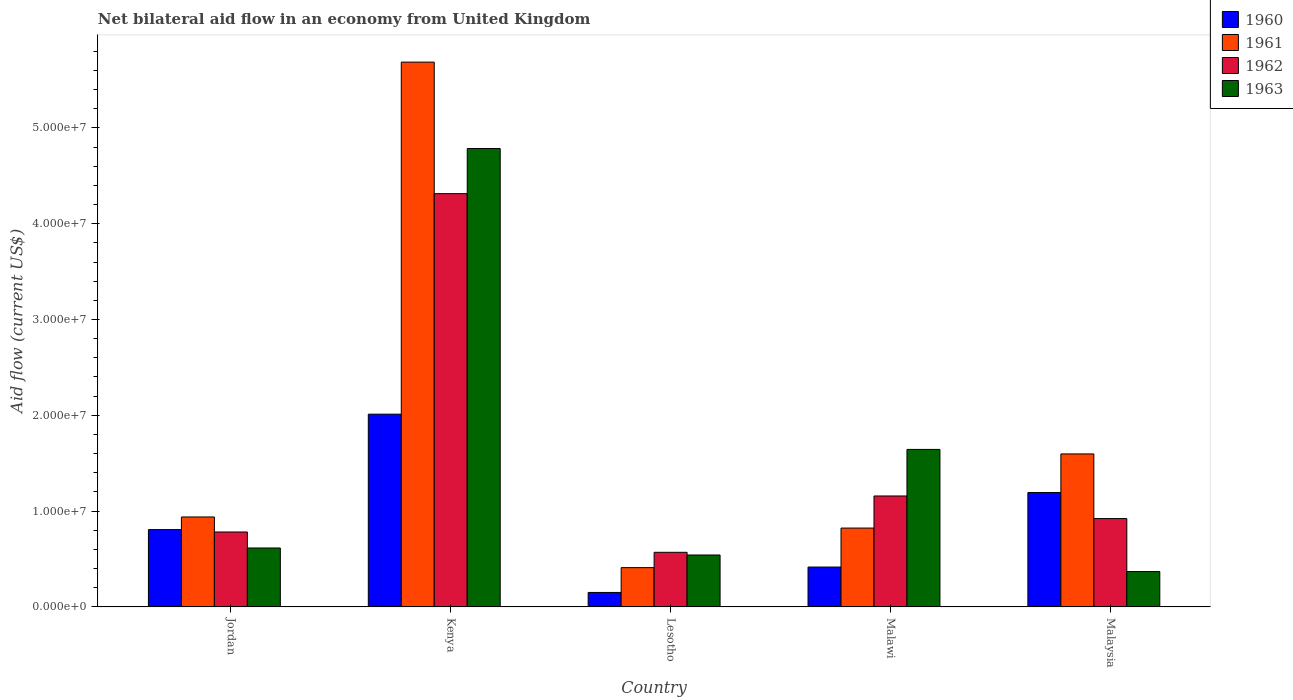How many groups of bars are there?
Your answer should be very brief. 5. Are the number of bars per tick equal to the number of legend labels?
Make the answer very short. Yes. Are the number of bars on each tick of the X-axis equal?
Provide a short and direct response. Yes. What is the label of the 2nd group of bars from the left?
Give a very brief answer. Kenya. In how many cases, is the number of bars for a given country not equal to the number of legend labels?
Your answer should be very brief. 0. What is the net bilateral aid flow in 1962 in Lesotho?
Offer a terse response. 5.70e+06. Across all countries, what is the maximum net bilateral aid flow in 1960?
Your answer should be compact. 2.01e+07. Across all countries, what is the minimum net bilateral aid flow in 1961?
Ensure brevity in your answer.  4.10e+06. In which country was the net bilateral aid flow in 1963 maximum?
Your answer should be very brief. Kenya. In which country was the net bilateral aid flow in 1963 minimum?
Your answer should be very brief. Malaysia. What is the total net bilateral aid flow in 1960 in the graph?
Your answer should be compact. 4.58e+07. What is the difference between the net bilateral aid flow in 1962 in Lesotho and that in Malaysia?
Provide a succinct answer. -3.52e+06. What is the difference between the net bilateral aid flow in 1960 in Malaysia and the net bilateral aid flow in 1962 in Lesotho?
Make the answer very short. 6.24e+06. What is the average net bilateral aid flow in 1960 per country?
Ensure brevity in your answer.  9.16e+06. What is the difference between the net bilateral aid flow of/in 1960 and net bilateral aid flow of/in 1961 in Jordan?
Ensure brevity in your answer.  -1.32e+06. In how many countries, is the net bilateral aid flow in 1962 greater than 28000000 US$?
Offer a terse response. 1. What is the ratio of the net bilateral aid flow in 1961 in Kenya to that in Malaysia?
Your answer should be compact. 3.56. What is the difference between the highest and the second highest net bilateral aid flow in 1963?
Your response must be concise. 4.17e+07. What is the difference between the highest and the lowest net bilateral aid flow in 1960?
Ensure brevity in your answer.  1.86e+07. In how many countries, is the net bilateral aid flow in 1960 greater than the average net bilateral aid flow in 1960 taken over all countries?
Ensure brevity in your answer.  2. What does the 4th bar from the left in Malawi represents?
Make the answer very short. 1963. Is it the case that in every country, the sum of the net bilateral aid flow in 1963 and net bilateral aid flow in 1962 is greater than the net bilateral aid flow in 1961?
Provide a succinct answer. No. Are all the bars in the graph horizontal?
Offer a very short reply. No. What is the difference between two consecutive major ticks on the Y-axis?
Give a very brief answer. 1.00e+07. Does the graph contain any zero values?
Offer a very short reply. No. Does the graph contain grids?
Provide a succinct answer. No. Where does the legend appear in the graph?
Keep it short and to the point. Top right. How are the legend labels stacked?
Provide a succinct answer. Vertical. What is the title of the graph?
Your answer should be compact. Net bilateral aid flow in an economy from United Kingdom. Does "1968" appear as one of the legend labels in the graph?
Provide a short and direct response. No. What is the Aid flow (current US$) in 1960 in Jordan?
Your answer should be compact. 8.07e+06. What is the Aid flow (current US$) of 1961 in Jordan?
Keep it short and to the point. 9.39e+06. What is the Aid flow (current US$) in 1962 in Jordan?
Provide a succinct answer. 7.82e+06. What is the Aid flow (current US$) of 1963 in Jordan?
Offer a terse response. 6.15e+06. What is the Aid flow (current US$) in 1960 in Kenya?
Your answer should be compact. 2.01e+07. What is the Aid flow (current US$) in 1961 in Kenya?
Provide a short and direct response. 5.69e+07. What is the Aid flow (current US$) of 1962 in Kenya?
Make the answer very short. 4.31e+07. What is the Aid flow (current US$) in 1963 in Kenya?
Ensure brevity in your answer.  4.78e+07. What is the Aid flow (current US$) of 1960 in Lesotho?
Provide a succinct answer. 1.51e+06. What is the Aid flow (current US$) in 1961 in Lesotho?
Keep it short and to the point. 4.10e+06. What is the Aid flow (current US$) of 1962 in Lesotho?
Offer a very short reply. 5.70e+06. What is the Aid flow (current US$) of 1963 in Lesotho?
Provide a short and direct response. 5.42e+06. What is the Aid flow (current US$) in 1960 in Malawi?
Offer a very short reply. 4.16e+06. What is the Aid flow (current US$) of 1961 in Malawi?
Provide a short and direct response. 8.23e+06. What is the Aid flow (current US$) of 1962 in Malawi?
Your answer should be very brief. 1.16e+07. What is the Aid flow (current US$) of 1963 in Malawi?
Give a very brief answer. 1.64e+07. What is the Aid flow (current US$) in 1960 in Malaysia?
Provide a succinct answer. 1.19e+07. What is the Aid flow (current US$) in 1961 in Malaysia?
Provide a succinct answer. 1.60e+07. What is the Aid flow (current US$) in 1962 in Malaysia?
Offer a very short reply. 9.22e+06. What is the Aid flow (current US$) of 1963 in Malaysia?
Keep it short and to the point. 3.69e+06. Across all countries, what is the maximum Aid flow (current US$) of 1960?
Offer a terse response. 2.01e+07. Across all countries, what is the maximum Aid flow (current US$) of 1961?
Offer a terse response. 5.69e+07. Across all countries, what is the maximum Aid flow (current US$) in 1962?
Offer a terse response. 4.31e+07. Across all countries, what is the maximum Aid flow (current US$) in 1963?
Your answer should be very brief. 4.78e+07. Across all countries, what is the minimum Aid flow (current US$) in 1960?
Your answer should be very brief. 1.51e+06. Across all countries, what is the minimum Aid flow (current US$) in 1961?
Offer a terse response. 4.10e+06. Across all countries, what is the minimum Aid flow (current US$) in 1962?
Provide a short and direct response. 5.70e+06. Across all countries, what is the minimum Aid flow (current US$) in 1963?
Your response must be concise. 3.69e+06. What is the total Aid flow (current US$) of 1960 in the graph?
Offer a terse response. 4.58e+07. What is the total Aid flow (current US$) of 1961 in the graph?
Ensure brevity in your answer.  9.46e+07. What is the total Aid flow (current US$) of 1962 in the graph?
Offer a terse response. 7.75e+07. What is the total Aid flow (current US$) in 1963 in the graph?
Keep it short and to the point. 7.96e+07. What is the difference between the Aid flow (current US$) in 1960 in Jordan and that in Kenya?
Make the answer very short. -1.20e+07. What is the difference between the Aid flow (current US$) of 1961 in Jordan and that in Kenya?
Ensure brevity in your answer.  -4.75e+07. What is the difference between the Aid flow (current US$) of 1962 in Jordan and that in Kenya?
Ensure brevity in your answer.  -3.53e+07. What is the difference between the Aid flow (current US$) of 1963 in Jordan and that in Kenya?
Offer a very short reply. -4.17e+07. What is the difference between the Aid flow (current US$) of 1960 in Jordan and that in Lesotho?
Offer a terse response. 6.56e+06. What is the difference between the Aid flow (current US$) in 1961 in Jordan and that in Lesotho?
Your answer should be very brief. 5.29e+06. What is the difference between the Aid flow (current US$) of 1962 in Jordan and that in Lesotho?
Provide a short and direct response. 2.12e+06. What is the difference between the Aid flow (current US$) in 1963 in Jordan and that in Lesotho?
Provide a short and direct response. 7.30e+05. What is the difference between the Aid flow (current US$) of 1960 in Jordan and that in Malawi?
Keep it short and to the point. 3.91e+06. What is the difference between the Aid flow (current US$) in 1961 in Jordan and that in Malawi?
Provide a short and direct response. 1.16e+06. What is the difference between the Aid flow (current US$) in 1962 in Jordan and that in Malawi?
Your answer should be compact. -3.76e+06. What is the difference between the Aid flow (current US$) in 1963 in Jordan and that in Malawi?
Your answer should be compact. -1.03e+07. What is the difference between the Aid flow (current US$) of 1960 in Jordan and that in Malaysia?
Make the answer very short. -3.87e+06. What is the difference between the Aid flow (current US$) of 1961 in Jordan and that in Malaysia?
Offer a terse response. -6.58e+06. What is the difference between the Aid flow (current US$) of 1962 in Jordan and that in Malaysia?
Make the answer very short. -1.40e+06. What is the difference between the Aid flow (current US$) in 1963 in Jordan and that in Malaysia?
Make the answer very short. 2.46e+06. What is the difference between the Aid flow (current US$) in 1960 in Kenya and that in Lesotho?
Your answer should be compact. 1.86e+07. What is the difference between the Aid flow (current US$) in 1961 in Kenya and that in Lesotho?
Make the answer very short. 5.28e+07. What is the difference between the Aid flow (current US$) of 1962 in Kenya and that in Lesotho?
Provide a short and direct response. 3.74e+07. What is the difference between the Aid flow (current US$) in 1963 in Kenya and that in Lesotho?
Offer a terse response. 4.24e+07. What is the difference between the Aid flow (current US$) in 1960 in Kenya and that in Malawi?
Ensure brevity in your answer.  1.60e+07. What is the difference between the Aid flow (current US$) in 1961 in Kenya and that in Malawi?
Provide a succinct answer. 4.86e+07. What is the difference between the Aid flow (current US$) of 1962 in Kenya and that in Malawi?
Give a very brief answer. 3.16e+07. What is the difference between the Aid flow (current US$) in 1963 in Kenya and that in Malawi?
Make the answer very short. 3.14e+07. What is the difference between the Aid flow (current US$) in 1960 in Kenya and that in Malaysia?
Provide a short and direct response. 8.18e+06. What is the difference between the Aid flow (current US$) in 1961 in Kenya and that in Malaysia?
Offer a very short reply. 4.09e+07. What is the difference between the Aid flow (current US$) in 1962 in Kenya and that in Malaysia?
Offer a very short reply. 3.39e+07. What is the difference between the Aid flow (current US$) in 1963 in Kenya and that in Malaysia?
Offer a very short reply. 4.42e+07. What is the difference between the Aid flow (current US$) in 1960 in Lesotho and that in Malawi?
Provide a succinct answer. -2.65e+06. What is the difference between the Aid flow (current US$) in 1961 in Lesotho and that in Malawi?
Give a very brief answer. -4.13e+06. What is the difference between the Aid flow (current US$) in 1962 in Lesotho and that in Malawi?
Provide a short and direct response. -5.88e+06. What is the difference between the Aid flow (current US$) of 1963 in Lesotho and that in Malawi?
Provide a succinct answer. -1.10e+07. What is the difference between the Aid flow (current US$) in 1960 in Lesotho and that in Malaysia?
Make the answer very short. -1.04e+07. What is the difference between the Aid flow (current US$) of 1961 in Lesotho and that in Malaysia?
Offer a very short reply. -1.19e+07. What is the difference between the Aid flow (current US$) in 1962 in Lesotho and that in Malaysia?
Offer a very short reply. -3.52e+06. What is the difference between the Aid flow (current US$) of 1963 in Lesotho and that in Malaysia?
Make the answer very short. 1.73e+06. What is the difference between the Aid flow (current US$) of 1960 in Malawi and that in Malaysia?
Offer a terse response. -7.78e+06. What is the difference between the Aid flow (current US$) in 1961 in Malawi and that in Malaysia?
Ensure brevity in your answer.  -7.74e+06. What is the difference between the Aid flow (current US$) in 1962 in Malawi and that in Malaysia?
Your response must be concise. 2.36e+06. What is the difference between the Aid flow (current US$) of 1963 in Malawi and that in Malaysia?
Give a very brief answer. 1.28e+07. What is the difference between the Aid flow (current US$) of 1960 in Jordan and the Aid flow (current US$) of 1961 in Kenya?
Your response must be concise. -4.88e+07. What is the difference between the Aid flow (current US$) in 1960 in Jordan and the Aid flow (current US$) in 1962 in Kenya?
Your answer should be very brief. -3.51e+07. What is the difference between the Aid flow (current US$) in 1960 in Jordan and the Aid flow (current US$) in 1963 in Kenya?
Your answer should be very brief. -3.98e+07. What is the difference between the Aid flow (current US$) in 1961 in Jordan and the Aid flow (current US$) in 1962 in Kenya?
Your answer should be compact. -3.38e+07. What is the difference between the Aid flow (current US$) in 1961 in Jordan and the Aid flow (current US$) in 1963 in Kenya?
Your response must be concise. -3.85e+07. What is the difference between the Aid flow (current US$) in 1962 in Jordan and the Aid flow (current US$) in 1963 in Kenya?
Offer a terse response. -4.00e+07. What is the difference between the Aid flow (current US$) in 1960 in Jordan and the Aid flow (current US$) in 1961 in Lesotho?
Offer a terse response. 3.97e+06. What is the difference between the Aid flow (current US$) of 1960 in Jordan and the Aid flow (current US$) of 1962 in Lesotho?
Make the answer very short. 2.37e+06. What is the difference between the Aid flow (current US$) in 1960 in Jordan and the Aid flow (current US$) in 1963 in Lesotho?
Make the answer very short. 2.65e+06. What is the difference between the Aid flow (current US$) of 1961 in Jordan and the Aid flow (current US$) of 1962 in Lesotho?
Offer a terse response. 3.69e+06. What is the difference between the Aid flow (current US$) in 1961 in Jordan and the Aid flow (current US$) in 1963 in Lesotho?
Keep it short and to the point. 3.97e+06. What is the difference between the Aid flow (current US$) of 1962 in Jordan and the Aid flow (current US$) of 1963 in Lesotho?
Offer a very short reply. 2.40e+06. What is the difference between the Aid flow (current US$) of 1960 in Jordan and the Aid flow (current US$) of 1962 in Malawi?
Make the answer very short. -3.51e+06. What is the difference between the Aid flow (current US$) of 1960 in Jordan and the Aid flow (current US$) of 1963 in Malawi?
Make the answer very short. -8.37e+06. What is the difference between the Aid flow (current US$) in 1961 in Jordan and the Aid flow (current US$) in 1962 in Malawi?
Make the answer very short. -2.19e+06. What is the difference between the Aid flow (current US$) of 1961 in Jordan and the Aid flow (current US$) of 1963 in Malawi?
Offer a very short reply. -7.05e+06. What is the difference between the Aid flow (current US$) of 1962 in Jordan and the Aid flow (current US$) of 1963 in Malawi?
Offer a terse response. -8.62e+06. What is the difference between the Aid flow (current US$) in 1960 in Jordan and the Aid flow (current US$) in 1961 in Malaysia?
Ensure brevity in your answer.  -7.90e+06. What is the difference between the Aid flow (current US$) in 1960 in Jordan and the Aid flow (current US$) in 1962 in Malaysia?
Your answer should be compact. -1.15e+06. What is the difference between the Aid flow (current US$) of 1960 in Jordan and the Aid flow (current US$) of 1963 in Malaysia?
Your response must be concise. 4.38e+06. What is the difference between the Aid flow (current US$) in 1961 in Jordan and the Aid flow (current US$) in 1963 in Malaysia?
Offer a terse response. 5.70e+06. What is the difference between the Aid flow (current US$) in 1962 in Jordan and the Aid flow (current US$) in 1963 in Malaysia?
Give a very brief answer. 4.13e+06. What is the difference between the Aid flow (current US$) of 1960 in Kenya and the Aid flow (current US$) of 1961 in Lesotho?
Provide a succinct answer. 1.60e+07. What is the difference between the Aid flow (current US$) in 1960 in Kenya and the Aid flow (current US$) in 1962 in Lesotho?
Provide a short and direct response. 1.44e+07. What is the difference between the Aid flow (current US$) in 1960 in Kenya and the Aid flow (current US$) in 1963 in Lesotho?
Your answer should be compact. 1.47e+07. What is the difference between the Aid flow (current US$) in 1961 in Kenya and the Aid flow (current US$) in 1962 in Lesotho?
Ensure brevity in your answer.  5.12e+07. What is the difference between the Aid flow (current US$) in 1961 in Kenya and the Aid flow (current US$) in 1963 in Lesotho?
Your answer should be compact. 5.14e+07. What is the difference between the Aid flow (current US$) in 1962 in Kenya and the Aid flow (current US$) in 1963 in Lesotho?
Make the answer very short. 3.77e+07. What is the difference between the Aid flow (current US$) of 1960 in Kenya and the Aid flow (current US$) of 1961 in Malawi?
Your answer should be compact. 1.19e+07. What is the difference between the Aid flow (current US$) of 1960 in Kenya and the Aid flow (current US$) of 1962 in Malawi?
Your response must be concise. 8.54e+06. What is the difference between the Aid flow (current US$) in 1960 in Kenya and the Aid flow (current US$) in 1963 in Malawi?
Provide a succinct answer. 3.68e+06. What is the difference between the Aid flow (current US$) in 1961 in Kenya and the Aid flow (current US$) in 1962 in Malawi?
Provide a short and direct response. 4.53e+07. What is the difference between the Aid flow (current US$) of 1961 in Kenya and the Aid flow (current US$) of 1963 in Malawi?
Your answer should be very brief. 4.04e+07. What is the difference between the Aid flow (current US$) in 1962 in Kenya and the Aid flow (current US$) in 1963 in Malawi?
Ensure brevity in your answer.  2.67e+07. What is the difference between the Aid flow (current US$) in 1960 in Kenya and the Aid flow (current US$) in 1961 in Malaysia?
Your response must be concise. 4.15e+06. What is the difference between the Aid flow (current US$) in 1960 in Kenya and the Aid flow (current US$) in 1962 in Malaysia?
Offer a very short reply. 1.09e+07. What is the difference between the Aid flow (current US$) in 1960 in Kenya and the Aid flow (current US$) in 1963 in Malaysia?
Provide a short and direct response. 1.64e+07. What is the difference between the Aid flow (current US$) of 1961 in Kenya and the Aid flow (current US$) of 1962 in Malaysia?
Offer a very short reply. 4.76e+07. What is the difference between the Aid flow (current US$) in 1961 in Kenya and the Aid flow (current US$) in 1963 in Malaysia?
Your answer should be very brief. 5.32e+07. What is the difference between the Aid flow (current US$) in 1962 in Kenya and the Aid flow (current US$) in 1963 in Malaysia?
Provide a short and direct response. 3.94e+07. What is the difference between the Aid flow (current US$) of 1960 in Lesotho and the Aid flow (current US$) of 1961 in Malawi?
Offer a terse response. -6.72e+06. What is the difference between the Aid flow (current US$) of 1960 in Lesotho and the Aid flow (current US$) of 1962 in Malawi?
Offer a very short reply. -1.01e+07. What is the difference between the Aid flow (current US$) in 1960 in Lesotho and the Aid flow (current US$) in 1963 in Malawi?
Provide a short and direct response. -1.49e+07. What is the difference between the Aid flow (current US$) of 1961 in Lesotho and the Aid flow (current US$) of 1962 in Malawi?
Make the answer very short. -7.48e+06. What is the difference between the Aid flow (current US$) of 1961 in Lesotho and the Aid flow (current US$) of 1963 in Malawi?
Your answer should be very brief. -1.23e+07. What is the difference between the Aid flow (current US$) of 1962 in Lesotho and the Aid flow (current US$) of 1963 in Malawi?
Offer a very short reply. -1.07e+07. What is the difference between the Aid flow (current US$) in 1960 in Lesotho and the Aid flow (current US$) in 1961 in Malaysia?
Your answer should be very brief. -1.45e+07. What is the difference between the Aid flow (current US$) of 1960 in Lesotho and the Aid flow (current US$) of 1962 in Malaysia?
Offer a terse response. -7.71e+06. What is the difference between the Aid flow (current US$) in 1960 in Lesotho and the Aid flow (current US$) in 1963 in Malaysia?
Your answer should be very brief. -2.18e+06. What is the difference between the Aid flow (current US$) of 1961 in Lesotho and the Aid flow (current US$) of 1962 in Malaysia?
Your answer should be compact. -5.12e+06. What is the difference between the Aid flow (current US$) in 1962 in Lesotho and the Aid flow (current US$) in 1963 in Malaysia?
Ensure brevity in your answer.  2.01e+06. What is the difference between the Aid flow (current US$) in 1960 in Malawi and the Aid flow (current US$) in 1961 in Malaysia?
Your answer should be very brief. -1.18e+07. What is the difference between the Aid flow (current US$) in 1960 in Malawi and the Aid flow (current US$) in 1962 in Malaysia?
Your answer should be very brief. -5.06e+06. What is the difference between the Aid flow (current US$) of 1961 in Malawi and the Aid flow (current US$) of 1962 in Malaysia?
Keep it short and to the point. -9.90e+05. What is the difference between the Aid flow (current US$) in 1961 in Malawi and the Aid flow (current US$) in 1963 in Malaysia?
Your response must be concise. 4.54e+06. What is the difference between the Aid flow (current US$) of 1962 in Malawi and the Aid flow (current US$) of 1963 in Malaysia?
Your answer should be very brief. 7.89e+06. What is the average Aid flow (current US$) of 1960 per country?
Offer a terse response. 9.16e+06. What is the average Aid flow (current US$) of 1961 per country?
Your answer should be very brief. 1.89e+07. What is the average Aid flow (current US$) in 1962 per country?
Give a very brief answer. 1.55e+07. What is the average Aid flow (current US$) of 1963 per country?
Ensure brevity in your answer.  1.59e+07. What is the difference between the Aid flow (current US$) in 1960 and Aid flow (current US$) in 1961 in Jordan?
Keep it short and to the point. -1.32e+06. What is the difference between the Aid flow (current US$) in 1960 and Aid flow (current US$) in 1963 in Jordan?
Your answer should be very brief. 1.92e+06. What is the difference between the Aid flow (current US$) in 1961 and Aid flow (current US$) in 1962 in Jordan?
Your answer should be compact. 1.57e+06. What is the difference between the Aid flow (current US$) of 1961 and Aid flow (current US$) of 1963 in Jordan?
Your answer should be compact. 3.24e+06. What is the difference between the Aid flow (current US$) of 1962 and Aid flow (current US$) of 1963 in Jordan?
Your response must be concise. 1.67e+06. What is the difference between the Aid flow (current US$) of 1960 and Aid flow (current US$) of 1961 in Kenya?
Give a very brief answer. -3.68e+07. What is the difference between the Aid flow (current US$) in 1960 and Aid flow (current US$) in 1962 in Kenya?
Offer a very short reply. -2.30e+07. What is the difference between the Aid flow (current US$) of 1960 and Aid flow (current US$) of 1963 in Kenya?
Offer a very short reply. -2.77e+07. What is the difference between the Aid flow (current US$) of 1961 and Aid flow (current US$) of 1962 in Kenya?
Your answer should be very brief. 1.37e+07. What is the difference between the Aid flow (current US$) of 1961 and Aid flow (current US$) of 1963 in Kenya?
Offer a terse response. 9.02e+06. What is the difference between the Aid flow (current US$) of 1962 and Aid flow (current US$) of 1963 in Kenya?
Your response must be concise. -4.71e+06. What is the difference between the Aid flow (current US$) in 1960 and Aid flow (current US$) in 1961 in Lesotho?
Provide a short and direct response. -2.59e+06. What is the difference between the Aid flow (current US$) of 1960 and Aid flow (current US$) of 1962 in Lesotho?
Keep it short and to the point. -4.19e+06. What is the difference between the Aid flow (current US$) of 1960 and Aid flow (current US$) of 1963 in Lesotho?
Keep it short and to the point. -3.91e+06. What is the difference between the Aid flow (current US$) of 1961 and Aid flow (current US$) of 1962 in Lesotho?
Provide a short and direct response. -1.60e+06. What is the difference between the Aid flow (current US$) of 1961 and Aid flow (current US$) of 1963 in Lesotho?
Ensure brevity in your answer.  -1.32e+06. What is the difference between the Aid flow (current US$) of 1962 and Aid flow (current US$) of 1963 in Lesotho?
Provide a short and direct response. 2.80e+05. What is the difference between the Aid flow (current US$) in 1960 and Aid flow (current US$) in 1961 in Malawi?
Ensure brevity in your answer.  -4.07e+06. What is the difference between the Aid flow (current US$) of 1960 and Aid flow (current US$) of 1962 in Malawi?
Provide a succinct answer. -7.42e+06. What is the difference between the Aid flow (current US$) of 1960 and Aid flow (current US$) of 1963 in Malawi?
Provide a short and direct response. -1.23e+07. What is the difference between the Aid flow (current US$) of 1961 and Aid flow (current US$) of 1962 in Malawi?
Make the answer very short. -3.35e+06. What is the difference between the Aid flow (current US$) in 1961 and Aid flow (current US$) in 1963 in Malawi?
Your answer should be compact. -8.21e+06. What is the difference between the Aid flow (current US$) of 1962 and Aid flow (current US$) of 1963 in Malawi?
Provide a succinct answer. -4.86e+06. What is the difference between the Aid flow (current US$) in 1960 and Aid flow (current US$) in 1961 in Malaysia?
Your answer should be very brief. -4.03e+06. What is the difference between the Aid flow (current US$) in 1960 and Aid flow (current US$) in 1962 in Malaysia?
Provide a succinct answer. 2.72e+06. What is the difference between the Aid flow (current US$) in 1960 and Aid flow (current US$) in 1963 in Malaysia?
Provide a short and direct response. 8.25e+06. What is the difference between the Aid flow (current US$) of 1961 and Aid flow (current US$) of 1962 in Malaysia?
Offer a very short reply. 6.75e+06. What is the difference between the Aid flow (current US$) of 1961 and Aid flow (current US$) of 1963 in Malaysia?
Make the answer very short. 1.23e+07. What is the difference between the Aid flow (current US$) in 1962 and Aid flow (current US$) in 1963 in Malaysia?
Provide a succinct answer. 5.53e+06. What is the ratio of the Aid flow (current US$) of 1960 in Jordan to that in Kenya?
Make the answer very short. 0.4. What is the ratio of the Aid flow (current US$) in 1961 in Jordan to that in Kenya?
Provide a succinct answer. 0.17. What is the ratio of the Aid flow (current US$) in 1962 in Jordan to that in Kenya?
Make the answer very short. 0.18. What is the ratio of the Aid flow (current US$) in 1963 in Jordan to that in Kenya?
Provide a succinct answer. 0.13. What is the ratio of the Aid flow (current US$) in 1960 in Jordan to that in Lesotho?
Offer a very short reply. 5.34. What is the ratio of the Aid flow (current US$) of 1961 in Jordan to that in Lesotho?
Ensure brevity in your answer.  2.29. What is the ratio of the Aid flow (current US$) of 1962 in Jordan to that in Lesotho?
Offer a terse response. 1.37. What is the ratio of the Aid flow (current US$) in 1963 in Jordan to that in Lesotho?
Ensure brevity in your answer.  1.13. What is the ratio of the Aid flow (current US$) of 1960 in Jordan to that in Malawi?
Your answer should be compact. 1.94. What is the ratio of the Aid flow (current US$) in 1961 in Jordan to that in Malawi?
Your response must be concise. 1.14. What is the ratio of the Aid flow (current US$) of 1962 in Jordan to that in Malawi?
Provide a short and direct response. 0.68. What is the ratio of the Aid flow (current US$) of 1963 in Jordan to that in Malawi?
Offer a very short reply. 0.37. What is the ratio of the Aid flow (current US$) of 1960 in Jordan to that in Malaysia?
Your answer should be very brief. 0.68. What is the ratio of the Aid flow (current US$) of 1961 in Jordan to that in Malaysia?
Keep it short and to the point. 0.59. What is the ratio of the Aid flow (current US$) of 1962 in Jordan to that in Malaysia?
Ensure brevity in your answer.  0.85. What is the ratio of the Aid flow (current US$) in 1960 in Kenya to that in Lesotho?
Keep it short and to the point. 13.32. What is the ratio of the Aid flow (current US$) of 1961 in Kenya to that in Lesotho?
Your answer should be very brief. 13.87. What is the ratio of the Aid flow (current US$) of 1962 in Kenya to that in Lesotho?
Your answer should be very brief. 7.57. What is the ratio of the Aid flow (current US$) of 1963 in Kenya to that in Lesotho?
Offer a terse response. 8.83. What is the ratio of the Aid flow (current US$) of 1960 in Kenya to that in Malawi?
Offer a very short reply. 4.84. What is the ratio of the Aid flow (current US$) in 1961 in Kenya to that in Malawi?
Provide a short and direct response. 6.91. What is the ratio of the Aid flow (current US$) in 1962 in Kenya to that in Malawi?
Make the answer very short. 3.73. What is the ratio of the Aid flow (current US$) of 1963 in Kenya to that in Malawi?
Ensure brevity in your answer.  2.91. What is the ratio of the Aid flow (current US$) in 1960 in Kenya to that in Malaysia?
Give a very brief answer. 1.69. What is the ratio of the Aid flow (current US$) in 1961 in Kenya to that in Malaysia?
Offer a very short reply. 3.56. What is the ratio of the Aid flow (current US$) in 1962 in Kenya to that in Malaysia?
Ensure brevity in your answer.  4.68. What is the ratio of the Aid flow (current US$) in 1963 in Kenya to that in Malaysia?
Your answer should be compact. 12.97. What is the ratio of the Aid flow (current US$) in 1960 in Lesotho to that in Malawi?
Offer a very short reply. 0.36. What is the ratio of the Aid flow (current US$) of 1961 in Lesotho to that in Malawi?
Your answer should be compact. 0.5. What is the ratio of the Aid flow (current US$) in 1962 in Lesotho to that in Malawi?
Give a very brief answer. 0.49. What is the ratio of the Aid flow (current US$) in 1963 in Lesotho to that in Malawi?
Ensure brevity in your answer.  0.33. What is the ratio of the Aid flow (current US$) of 1960 in Lesotho to that in Malaysia?
Provide a short and direct response. 0.13. What is the ratio of the Aid flow (current US$) in 1961 in Lesotho to that in Malaysia?
Make the answer very short. 0.26. What is the ratio of the Aid flow (current US$) in 1962 in Lesotho to that in Malaysia?
Ensure brevity in your answer.  0.62. What is the ratio of the Aid flow (current US$) of 1963 in Lesotho to that in Malaysia?
Ensure brevity in your answer.  1.47. What is the ratio of the Aid flow (current US$) of 1960 in Malawi to that in Malaysia?
Make the answer very short. 0.35. What is the ratio of the Aid flow (current US$) in 1961 in Malawi to that in Malaysia?
Your answer should be very brief. 0.52. What is the ratio of the Aid flow (current US$) in 1962 in Malawi to that in Malaysia?
Give a very brief answer. 1.26. What is the ratio of the Aid flow (current US$) of 1963 in Malawi to that in Malaysia?
Make the answer very short. 4.46. What is the difference between the highest and the second highest Aid flow (current US$) in 1960?
Keep it short and to the point. 8.18e+06. What is the difference between the highest and the second highest Aid flow (current US$) in 1961?
Your answer should be very brief. 4.09e+07. What is the difference between the highest and the second highest Aid flow (current US$) of 1962?
Offer a terse response. 3.16e+07. What is the difference between the highest and the second highest Aid flow (current US$) in 1963?
Give a very brief answer. 3.14e+07. What is the difference between the highest and the lowest Aid flow (current US$) in 1960?
Offer a terse response. 1.86e+07. What is the difference between the highest and the lowest Aid flow (current US$) of 1961?
Ensure brevity in your answer.  5.28e+07. What is the difference between the highest and the lowest Aid flow (current US$) of 1962?
Provide a short and direct response. 3.74e+07. What is the difference between the highest and the lowest Aid flow (current US$) of 1963?
Provide a short and direct response. 4.42e+07. 